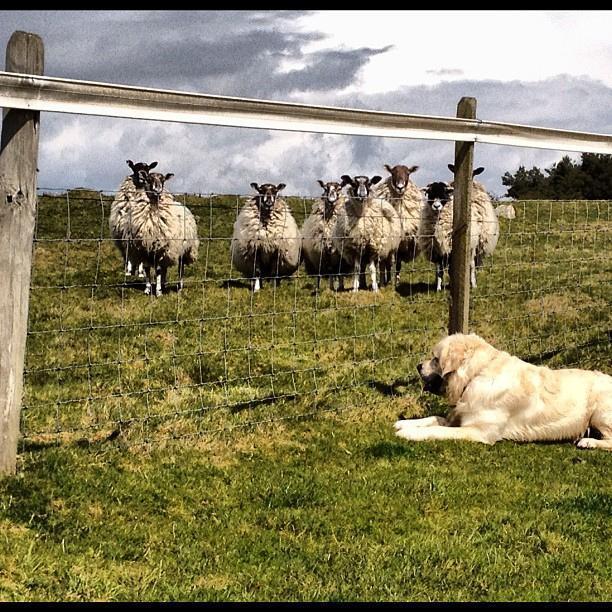How many sheep are in the picture?
Give a very brief answer. 8. How many sheep are in the photo?
Give a very brief answer. 7. 